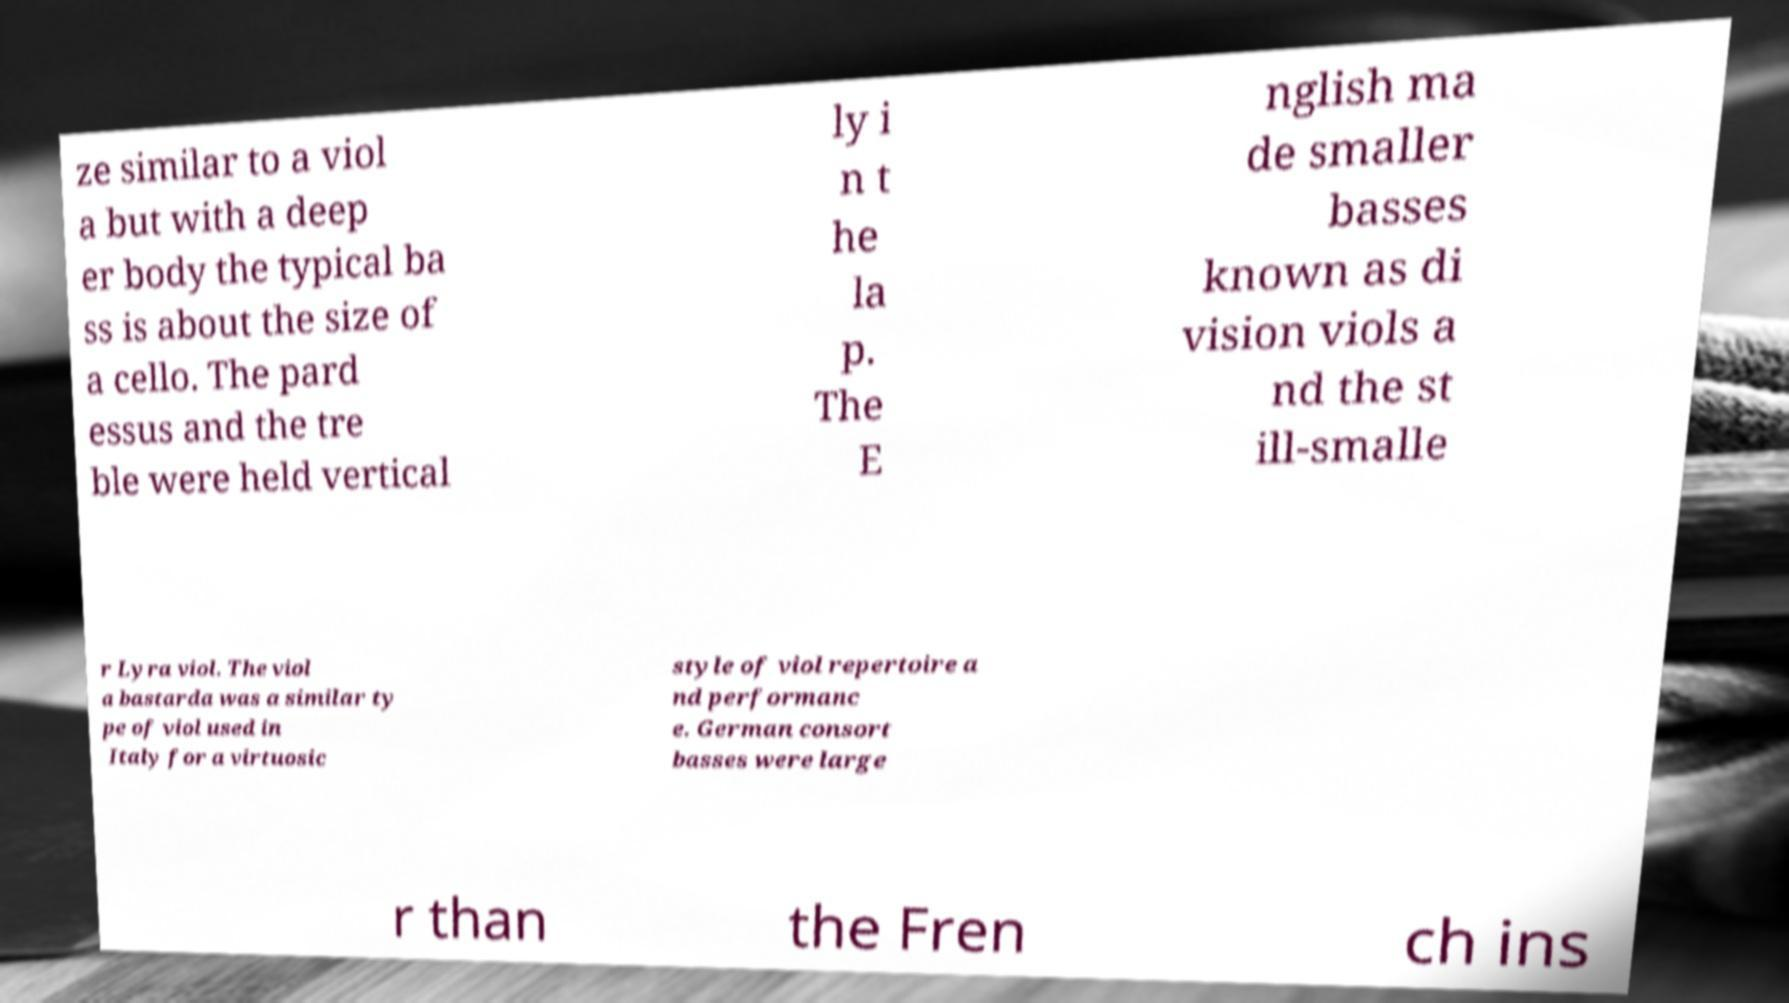There's text embedded in this image that I need extracted. Can you transcribe it verbatim? ze similar to a viol a but with a deep er body the typical ba ss is about the size of a cello. The pard essus and the tre ble were held vertical ly i n t he la p. The E nglish ma de smaller basses known as di vision viols a nd the st ill-smalle r Lyra viol. The viol a bastarda was a similar ty pe of viol used in Italy for a virtuosic style of viol repertoire a nd performanc e. German consort basses were large r than the Fren ch ins 